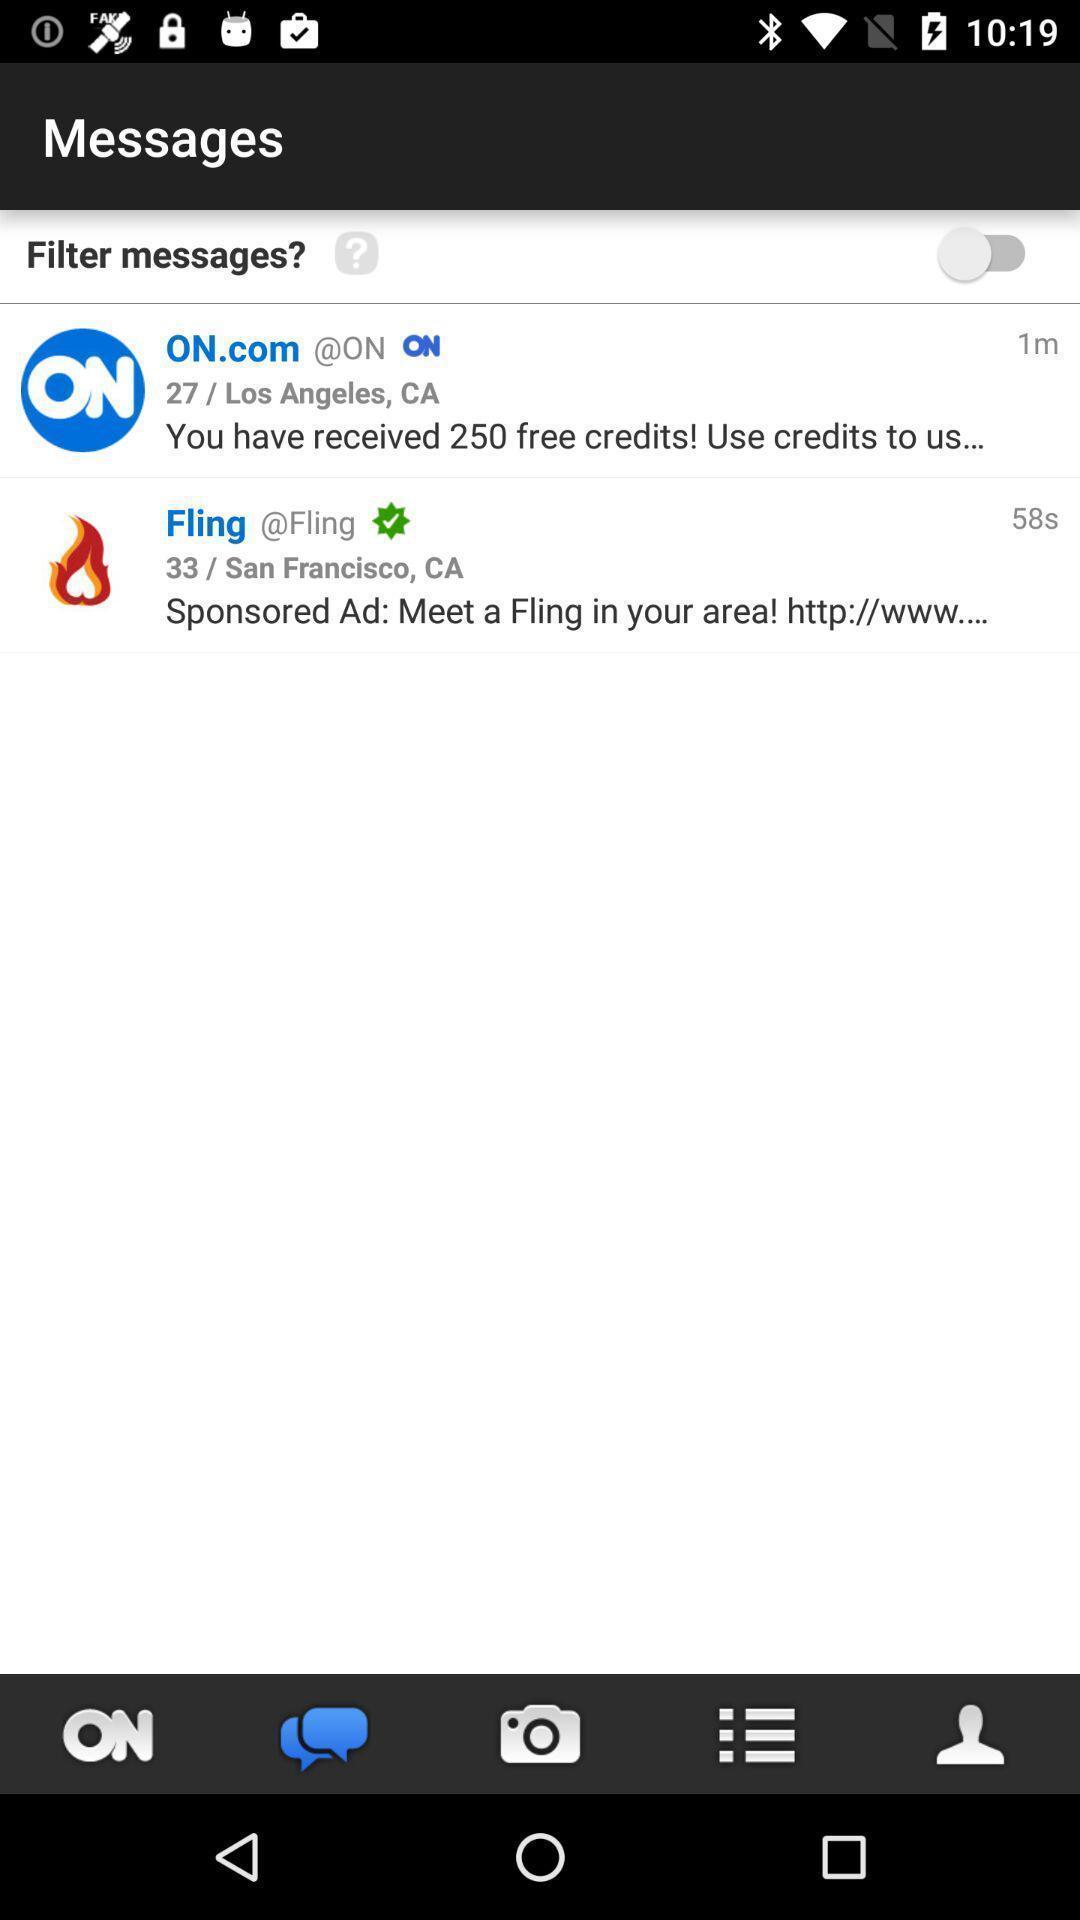Please provide a description for this image. Screen showing chat page of a social app. 